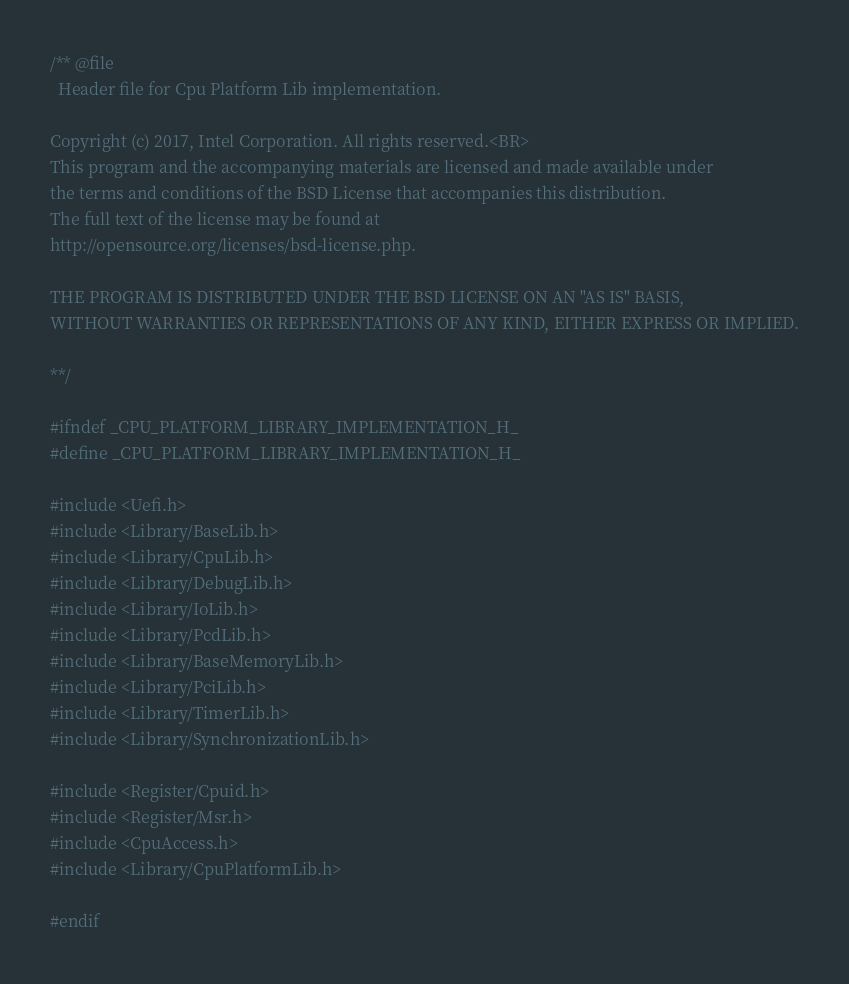<code> <loc_0><loc_0><loc_500><loc_500><_C_>/** @file
  Header file for Cpu Platform Lib implementation.

Copyright (c) 2017, Intel Corporation. All rights reserved.<BR>
This program and the accompanying materials are licensed and made available under
the terms and conditions of the BSD License that accompanies this distribution.
The full text of the license may be found at
http://opensource.org/licenses/bsd-license.php.

THE PROGRAM IS DISTRIBUTED UNDER THE BSD LICENSE ON AN "AS IS" BASIS,
WITHOUT WARRANTIES OR REPRESENTATIONS OF ANY KIND, EITHER EXPRESS OR IMPLIED.

**/

#ifndef _CPU_PLATFORM_LIBRARY_IMPLEMENTATION_H_
#define _CPU_PLATFORM_LIBRARY_IMPLEMENTATION_H_

#include <Uefi.h>
#include <Library/BaseLib.h>
#include <Library/CpuLib.h>
#include <Library/DebugLib.h>
#include <Library/IoLib.h>
#include <Library/PcdLib.h>
#include <Library/BaseMemoryLib.h>
#include <Library/PciLib.h>
#include <Library/TimerLib.h>
#include <Library/SynchronizationLib.h>

#include <Register/Cpuid.h>
#include <Register/Msr.h>
#include <CpuAccess.h>
#include <Library/CpuPlatformLib.h>

#endif
</code> 